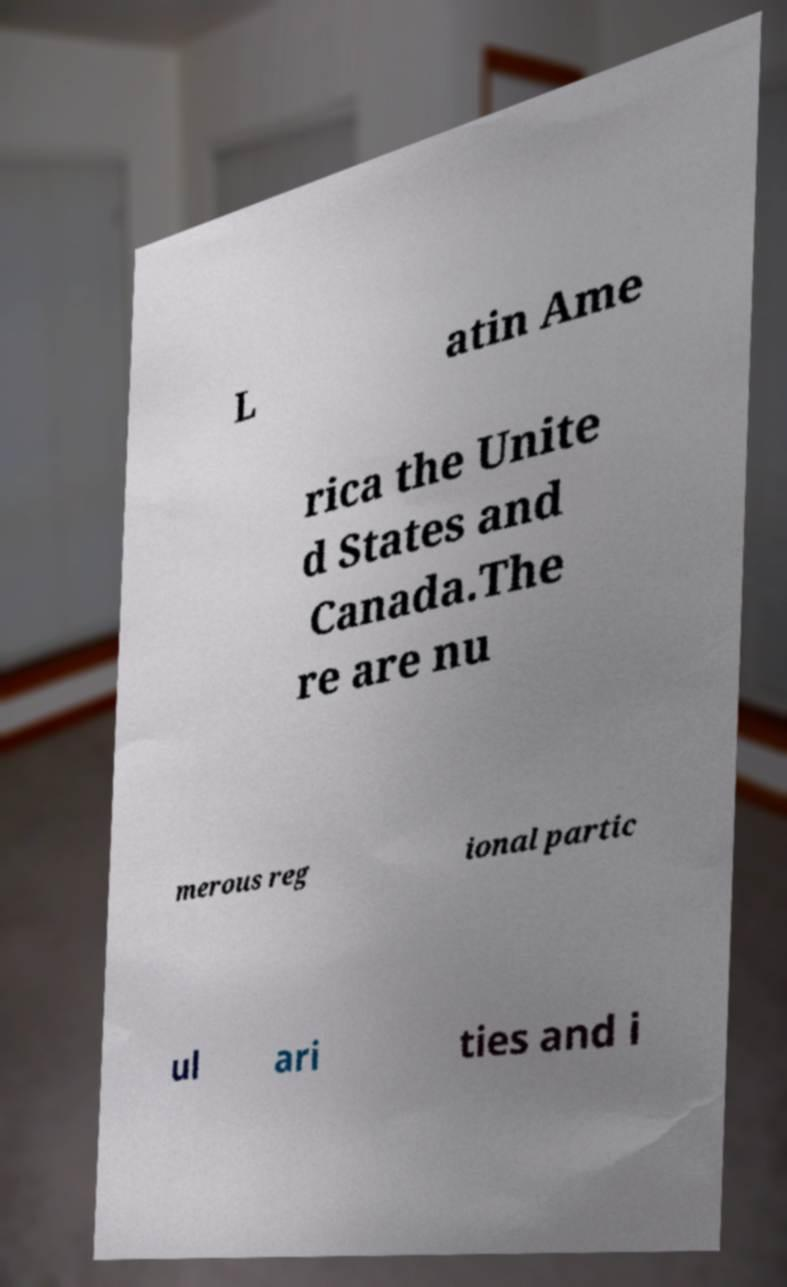Can you accurately transcribe the text from the provided image for me? L atin Ame rica the Unite d States and Canada.The re are nu merous reg ional partic ul ari ties and i 